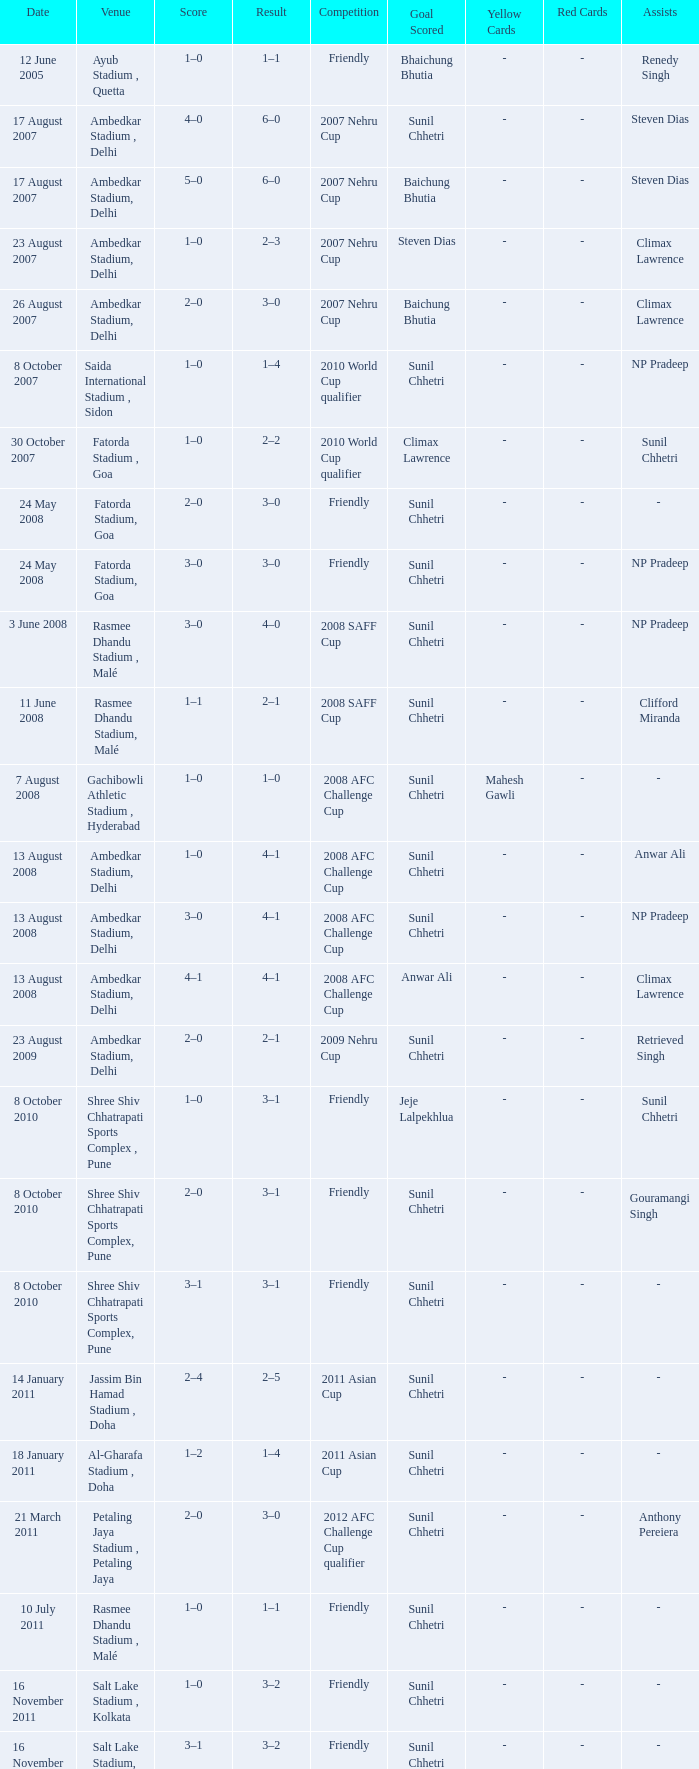Tell me the score on 22 august 2012 1–0. 